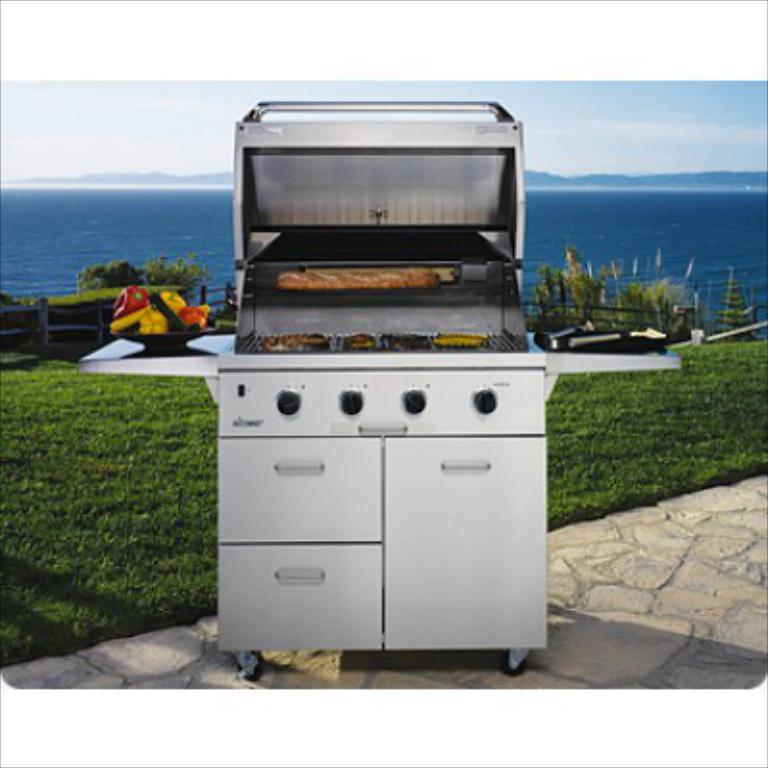What is the main object in the foreground of the image? There is a grill stove-like object in the foreground of the image. Where is the object located? The object is on the pavement. What type of vegetation is visible behind the object? There is grass behind the object. What can be seen in the background of the image? Water and the sky are visible in the background of the image. Are there any fairies flying around the grill in the image? There are no fairies visible in the image. What type of cracker is being used to cook on the grill in the image? There is no cracker present in the image, and the grill is not being used for cooking. 